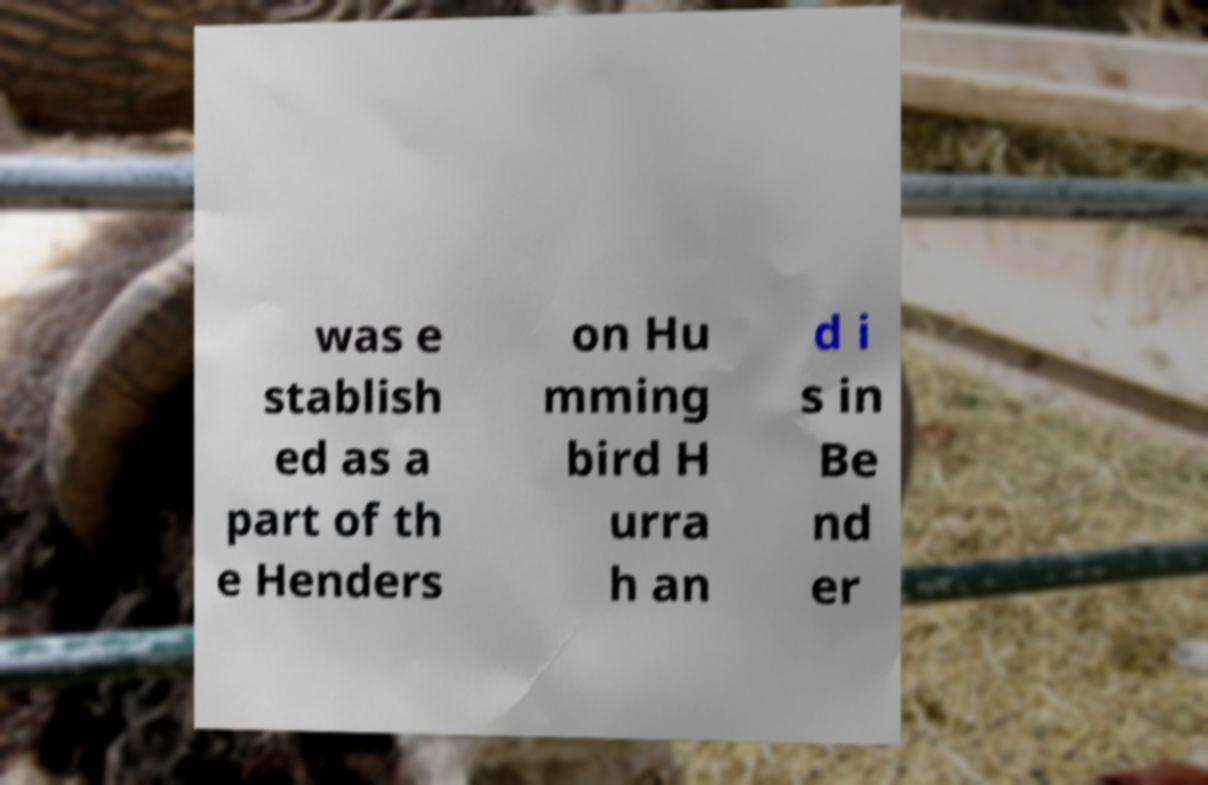Can you accurately transcribe the text from the provided image for me? was e stablish ed as a part of th e Henders on Hu mming bird H urra h an d i s in Be nd er 